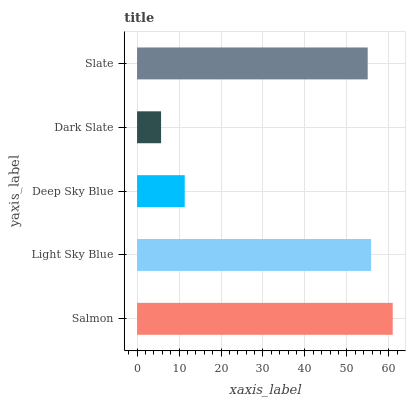Is Dark Slate the minimum?
Answer yes or no. Yes. Is Salmon the maximum?
Answer yes or no. Yes. Is Light Sky Blue the minimum?
Answer yes or no. No. Is Light Sky Blue the maximum?
Answer yes or no. No. Is Salmon greater than Light Sky Blue?
Answer yes or no. Yes. Is Light Sky Blue less than Salmon?
Answer yes or no. Yes. Is Light Sky Blue greater than Salmon?
Answer yes or no. No. Is Salmon less than Light Sky Blue?
Answer yes or no. No. Is Slate the high median?
Answer yes or no. Yes. Is Slate the low median?
Answer yes or no. Yes. Is Salmon the high median?
Answer yes or no. No. Is Light Sky Blue the low median?
Answer yes or no. No. 